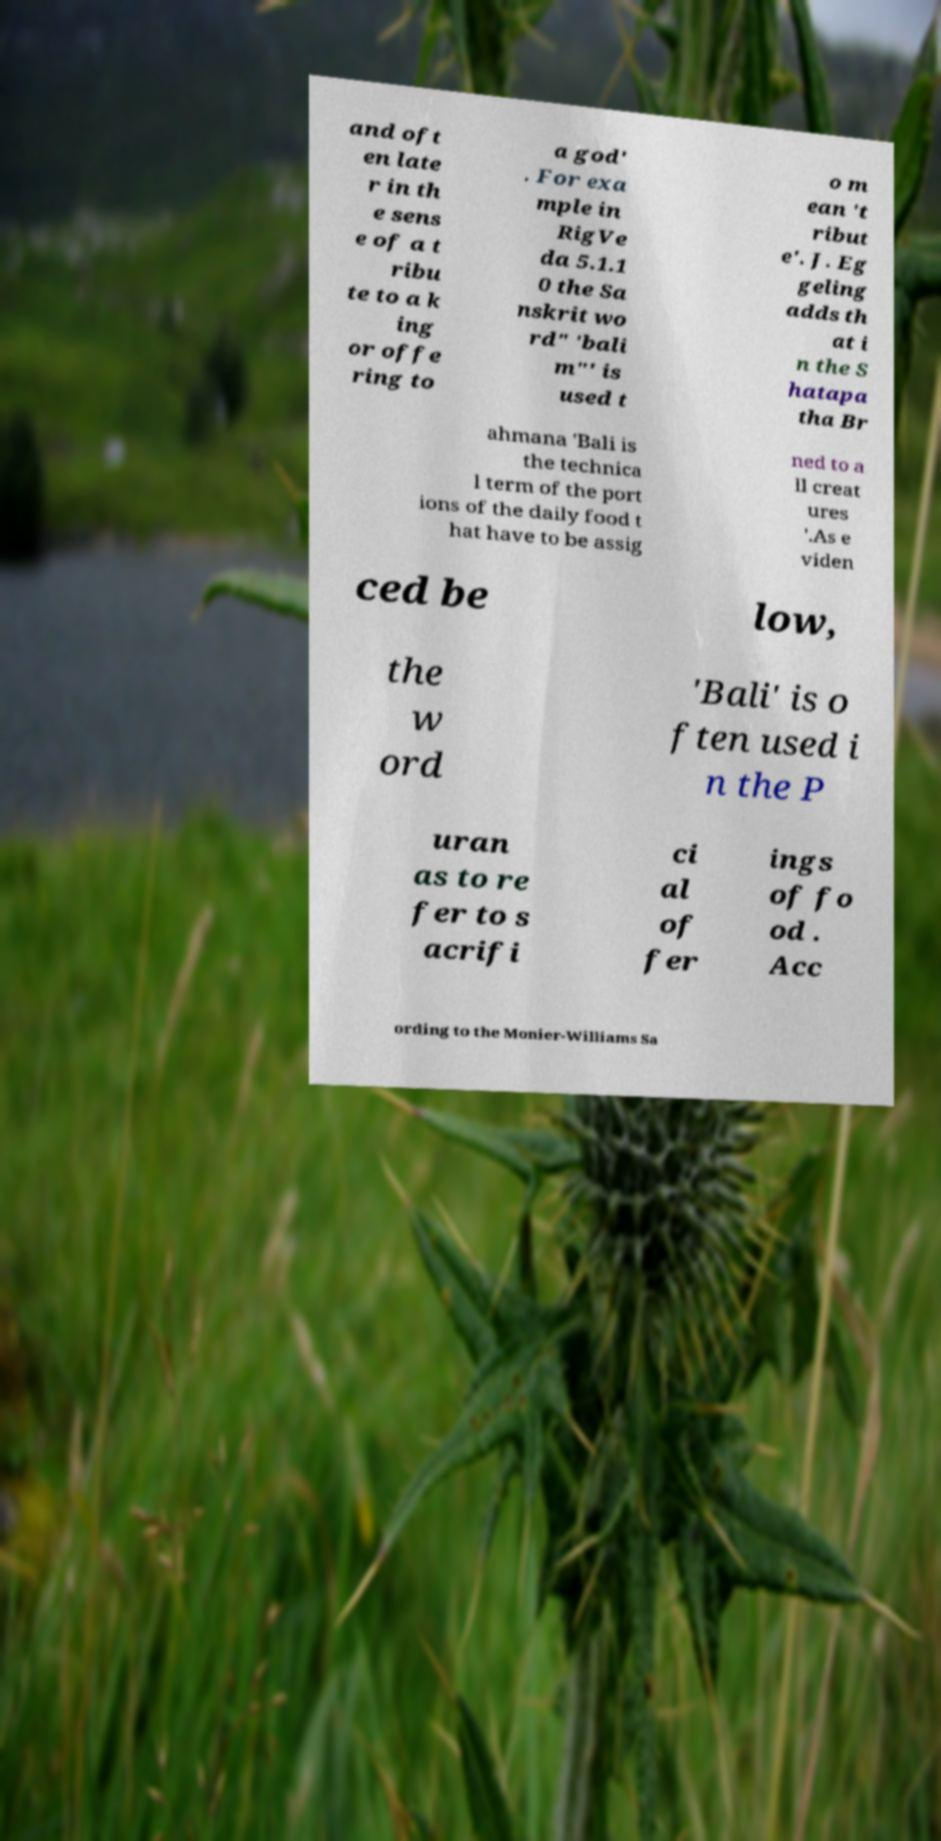Can you read and provide the text displayed in the image?This photo seems to have some interesting text. Can you extract and type it out for me? and oft en late r in th e sens e of a t ribu te to a k ing or offe ring to a god' . For exa mple in RigVe da 5.1.1 0 the Sa nskrit wo rd" 'bali m"' is used t o m ean 't ribut e'. J. Eg geling adds th at i n the S hatapa tha Br ahmana 'Bali is the technica l term of the port ions of the daily food t hat have to be assig ned to a ll creat ures '.As e viden ced be low, the w ord 'Bali' is o ften used i n the P uran as to re fer to s acrifi ci al of fer ings of fo od . Acc ording to the Monier-Williams Sa 